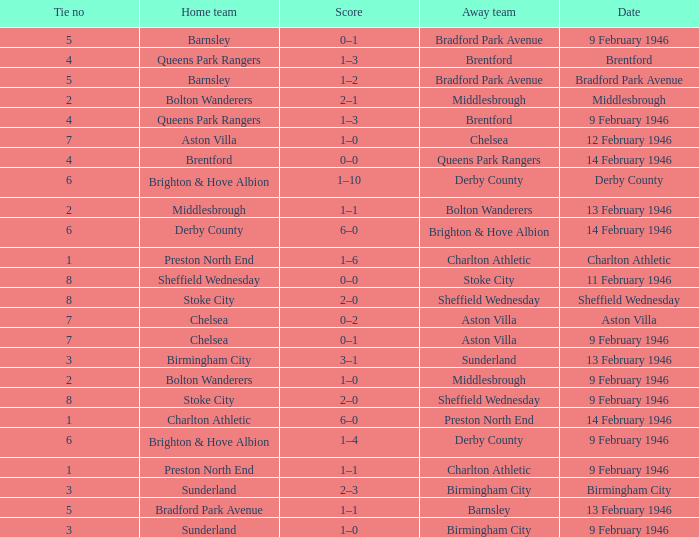What is the average Tie no when the date is Birmingham City? 3.0. 